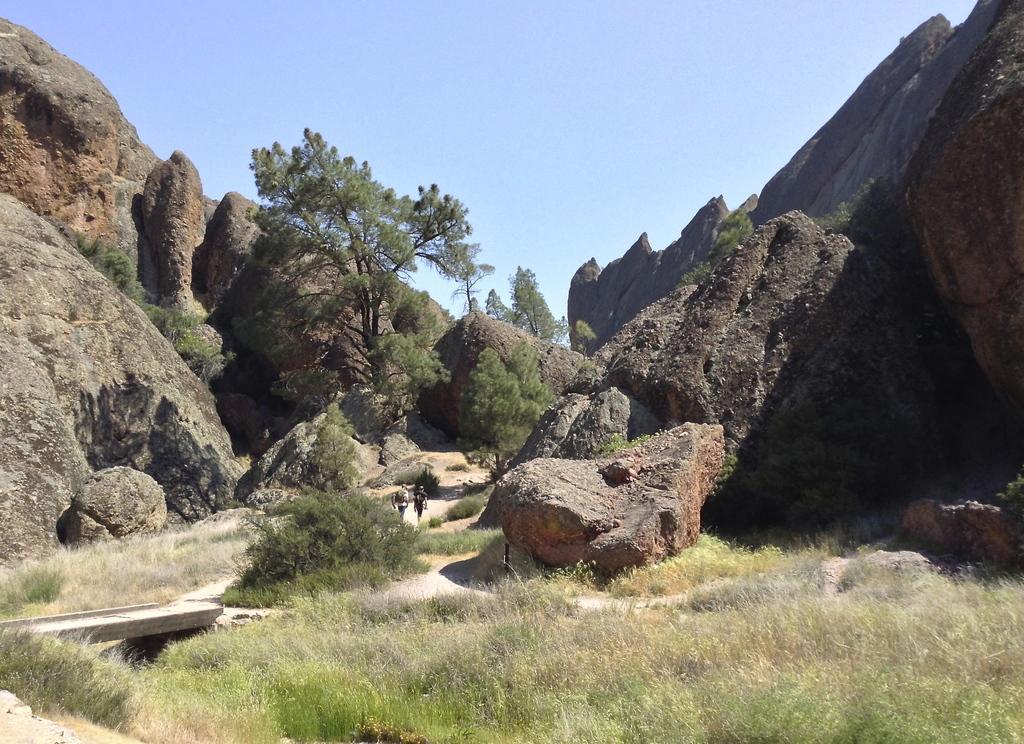Can you describe this image briefly? In this image I can see two persons walking, few trees in green color. In the background I can see few rocks and the sky is in blue and white color. 